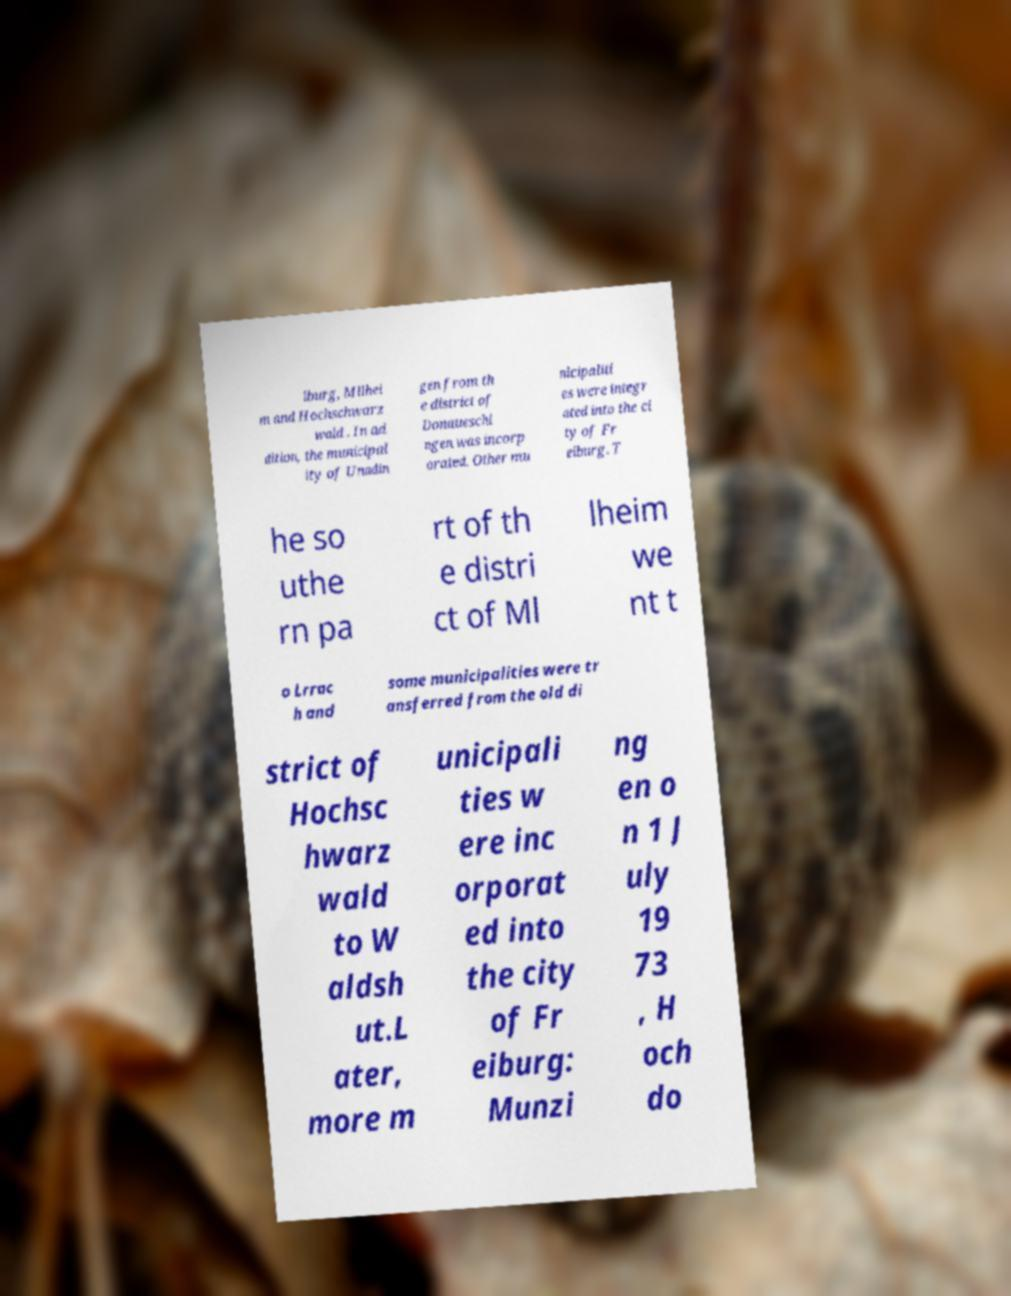Please read and relay the text visible in this image. What does it say? iburg, Mllhei m and Hochschwarz wald . In ad dition, the municipal ity of Unadin gen from th e district of Donaueschi ngen was incorp orated. Other mu nicipaliti es were integr ated into the ci ty of Fr eiburg. T he so uthe rn pa rt of th e distri ct of Ml lheim we nt t o Lrrac h and some municipalities were tr ansferred from the old di strict of Hochsc hwarz wald to W aldsh ut.L ater, more m unicipali ties w ere inc orporat ed into the city of Fr eiburg: Munzi ng en o n 1 J uly 19 73 , H och do 